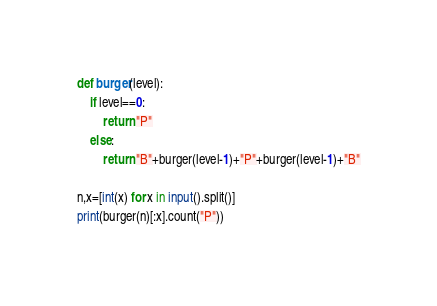Convert code to text. <code><loc_0><loc_0><loc_500><loc_500><_Python_>def burger(level):
    if level==0:
        return "P"
    else:
        return "B"+burger(level-1)+"P"+burger(level-1)+"B"

n,x=[int(x) for x in input().split()]
print(burger(n)[:x].count("P"))</code> 